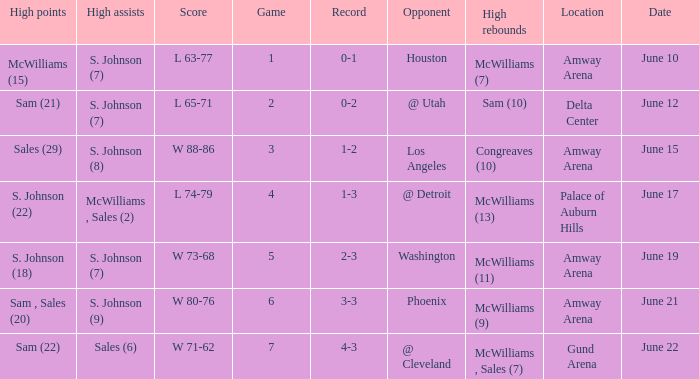Name the opponent for june 12 @ Utah. Write the full table. {'header': ['High points', 'High assists', 'Score', 'Game', 'Record', 'Opponent', 'High rebounds', 'Location', 'Date'], 'rows': [['McWilliams (15)', 'S. Johnson (7)', 'L 63-77', '1', '0-1', 'Houston', 'McWilliams (7)', 'Amway Arena', 'June 10'], ['Sam (21)', 'S. Johnson (7)', 'L 65-71', '2', '0-2', '@ Utah', 'Sam (10)', 'Delta Center', 'June 12'], ['Sales (29)', 'S. Johnson (8)', 'W 88-86', '3', '1-2', 'Los Angeles', 'Congreaves (10)', 'Amway Arena', 'June 15'], ['S. Johnson (22)', 'McWilliams , Sales (2)', 'L 74-79', '4', '1-3', '@ Detroit', 'McWilliams (13)', 'Palace of Auburn Hills', 'June 17'], ['S. Johnson (18)', 'S. Johnson (7)', 'W 73-68', '5', '2-3', 'Washington', 'McWilliams (11)', 'Amway Arena', 'June 19'], ['Sam , Sales (20)', 'S. Johnson (9)', 'W 80-76', '6', '3-3', 'Phoenix', 'McWilliams (9)', 'Amway Arena', 'June 21'], ['Sam (22)', 'Sales (6)', 'W 71-62', '7', '4-3', '@ Cleveland', 'McWilliams , Sales (7)', 'Gund Arena', 'June 22']]} 